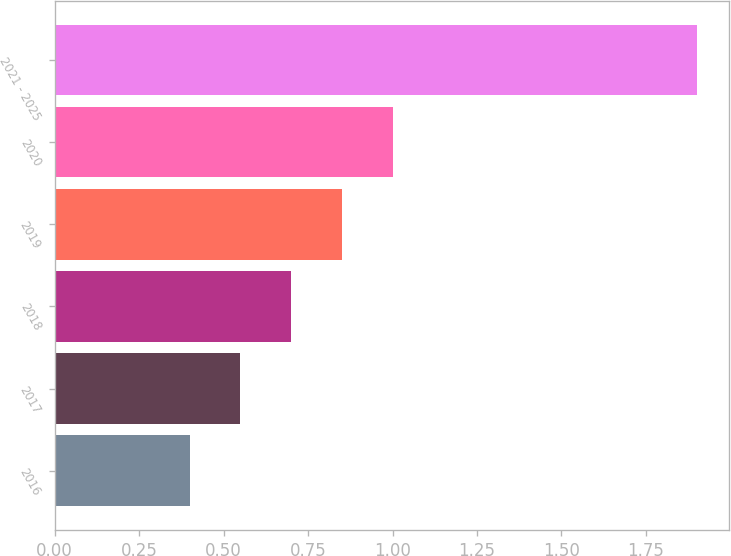Convert chart to OTSL. <chart><loc_0><loc_0><loc_500><loc_500><bar_chart><fcel>2016<fcel>2017<fcel>2018<fcel>2019<fcel>2020<fcel>2021 - 2025<nl><fcel>0.4<fcel>0.55<fcel>0.7<fcel>0.85<fcel>1<fcel>1.9<nl></chart> 